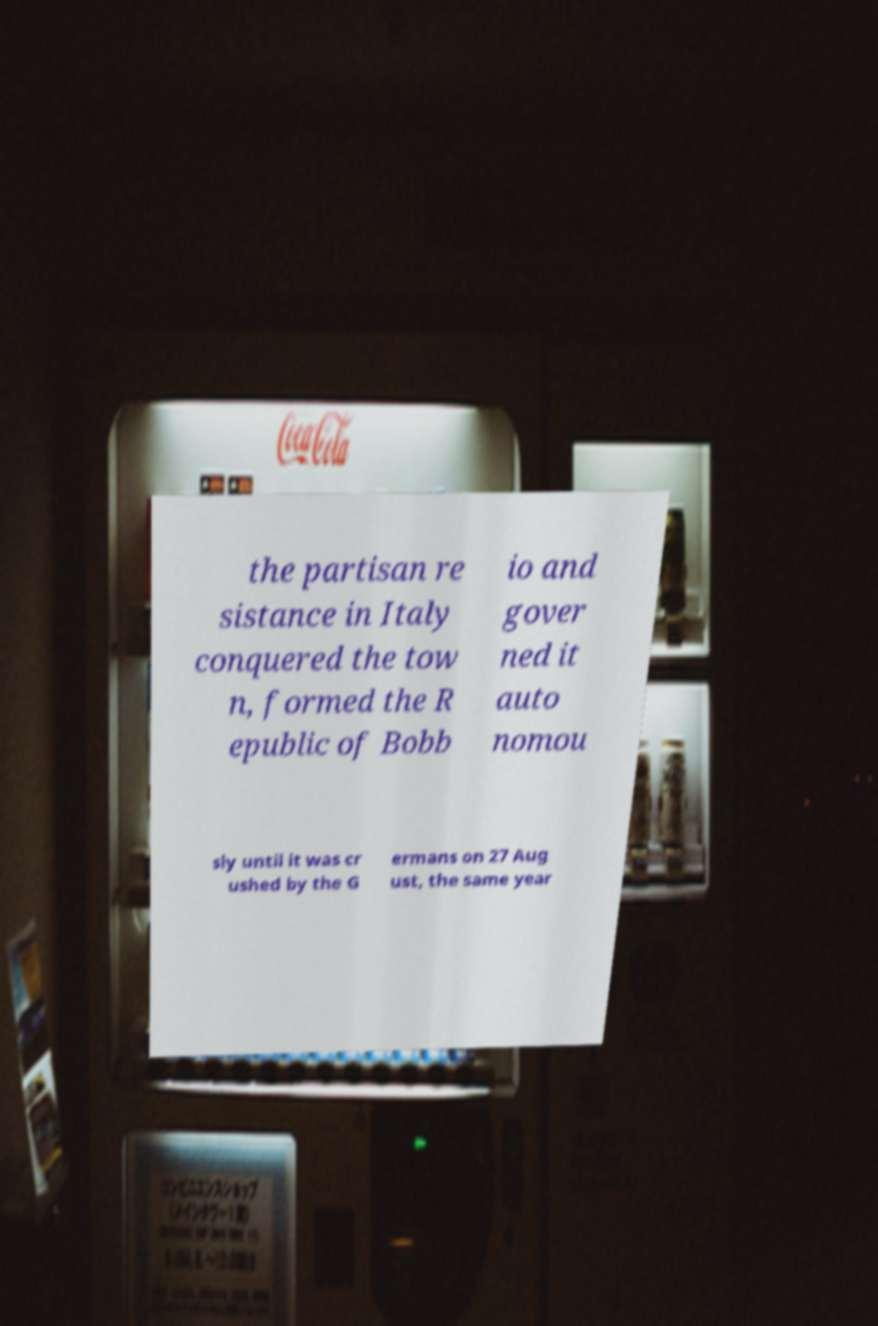What messages or text are displayed in this image? I need them in a readable, typed format. the partisan re sistance in Italy conquered the tow n, formed the R epublic of Bobb io and gover ned it auto nomou sly until it was cr ushed by the G ermans on 27 Aug ust, the same year 